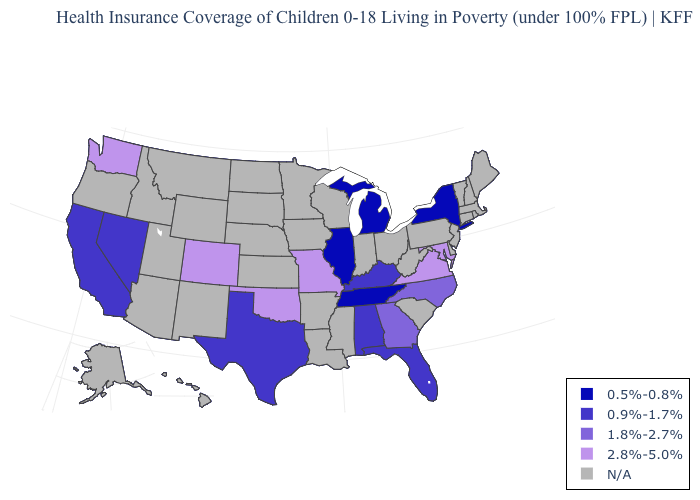What is the value of Pennsylvania?
Short answer required. N/A. What is the value of Alaska?
Write a very short answer. N/A. What is the value of Michigan?
Write a very short answer. 0.5%-0.8%. Does California have the highest value in the USA?
Concise answer only. No. How many symbols are there in the legend?
Be succinct. 5. What is the value of Pennsylvania?
Write a very short answer. N/A. What is the value of Kentucky?
Be succinct. 0.9%-1.7%. What is the value of Utah?
Keep it brief. N/A. What is the value of Indiana?
Write a very short answer. N/A. What is the value of Tennessee?
Concise answer only. 0.5%-0.8%. Does Oklahoma have the highest value in the South?
Concise answer only. Yes. What is the lowest value in the South?
Be succinct. 0.5%-0.8%. What is the value of South Carolina?
Write a very short answer. N/A. Name the states that have a value in the range N/A?
Short answer required. Alaska, Arizona, Arkansas, Connecticut, Delaware, Hawaii, Idaho, Indiana, Iowa, Kansas, Louisiana, Maine, Massachusetts, Minnesota, Mississippi, Montana, Nebraska, New Hampshire, New Jersey, New Mexico, North Dakota, Ohio, Oregon, Pennsylvania, Rhode Island, South Carolina, South Dakota, Utah, Vermont, West Virginia, Wisconsin, Wyoming. What is the highest value in states that border Wyoming?
Give a very brief answer. 2.8%-5.0%. 